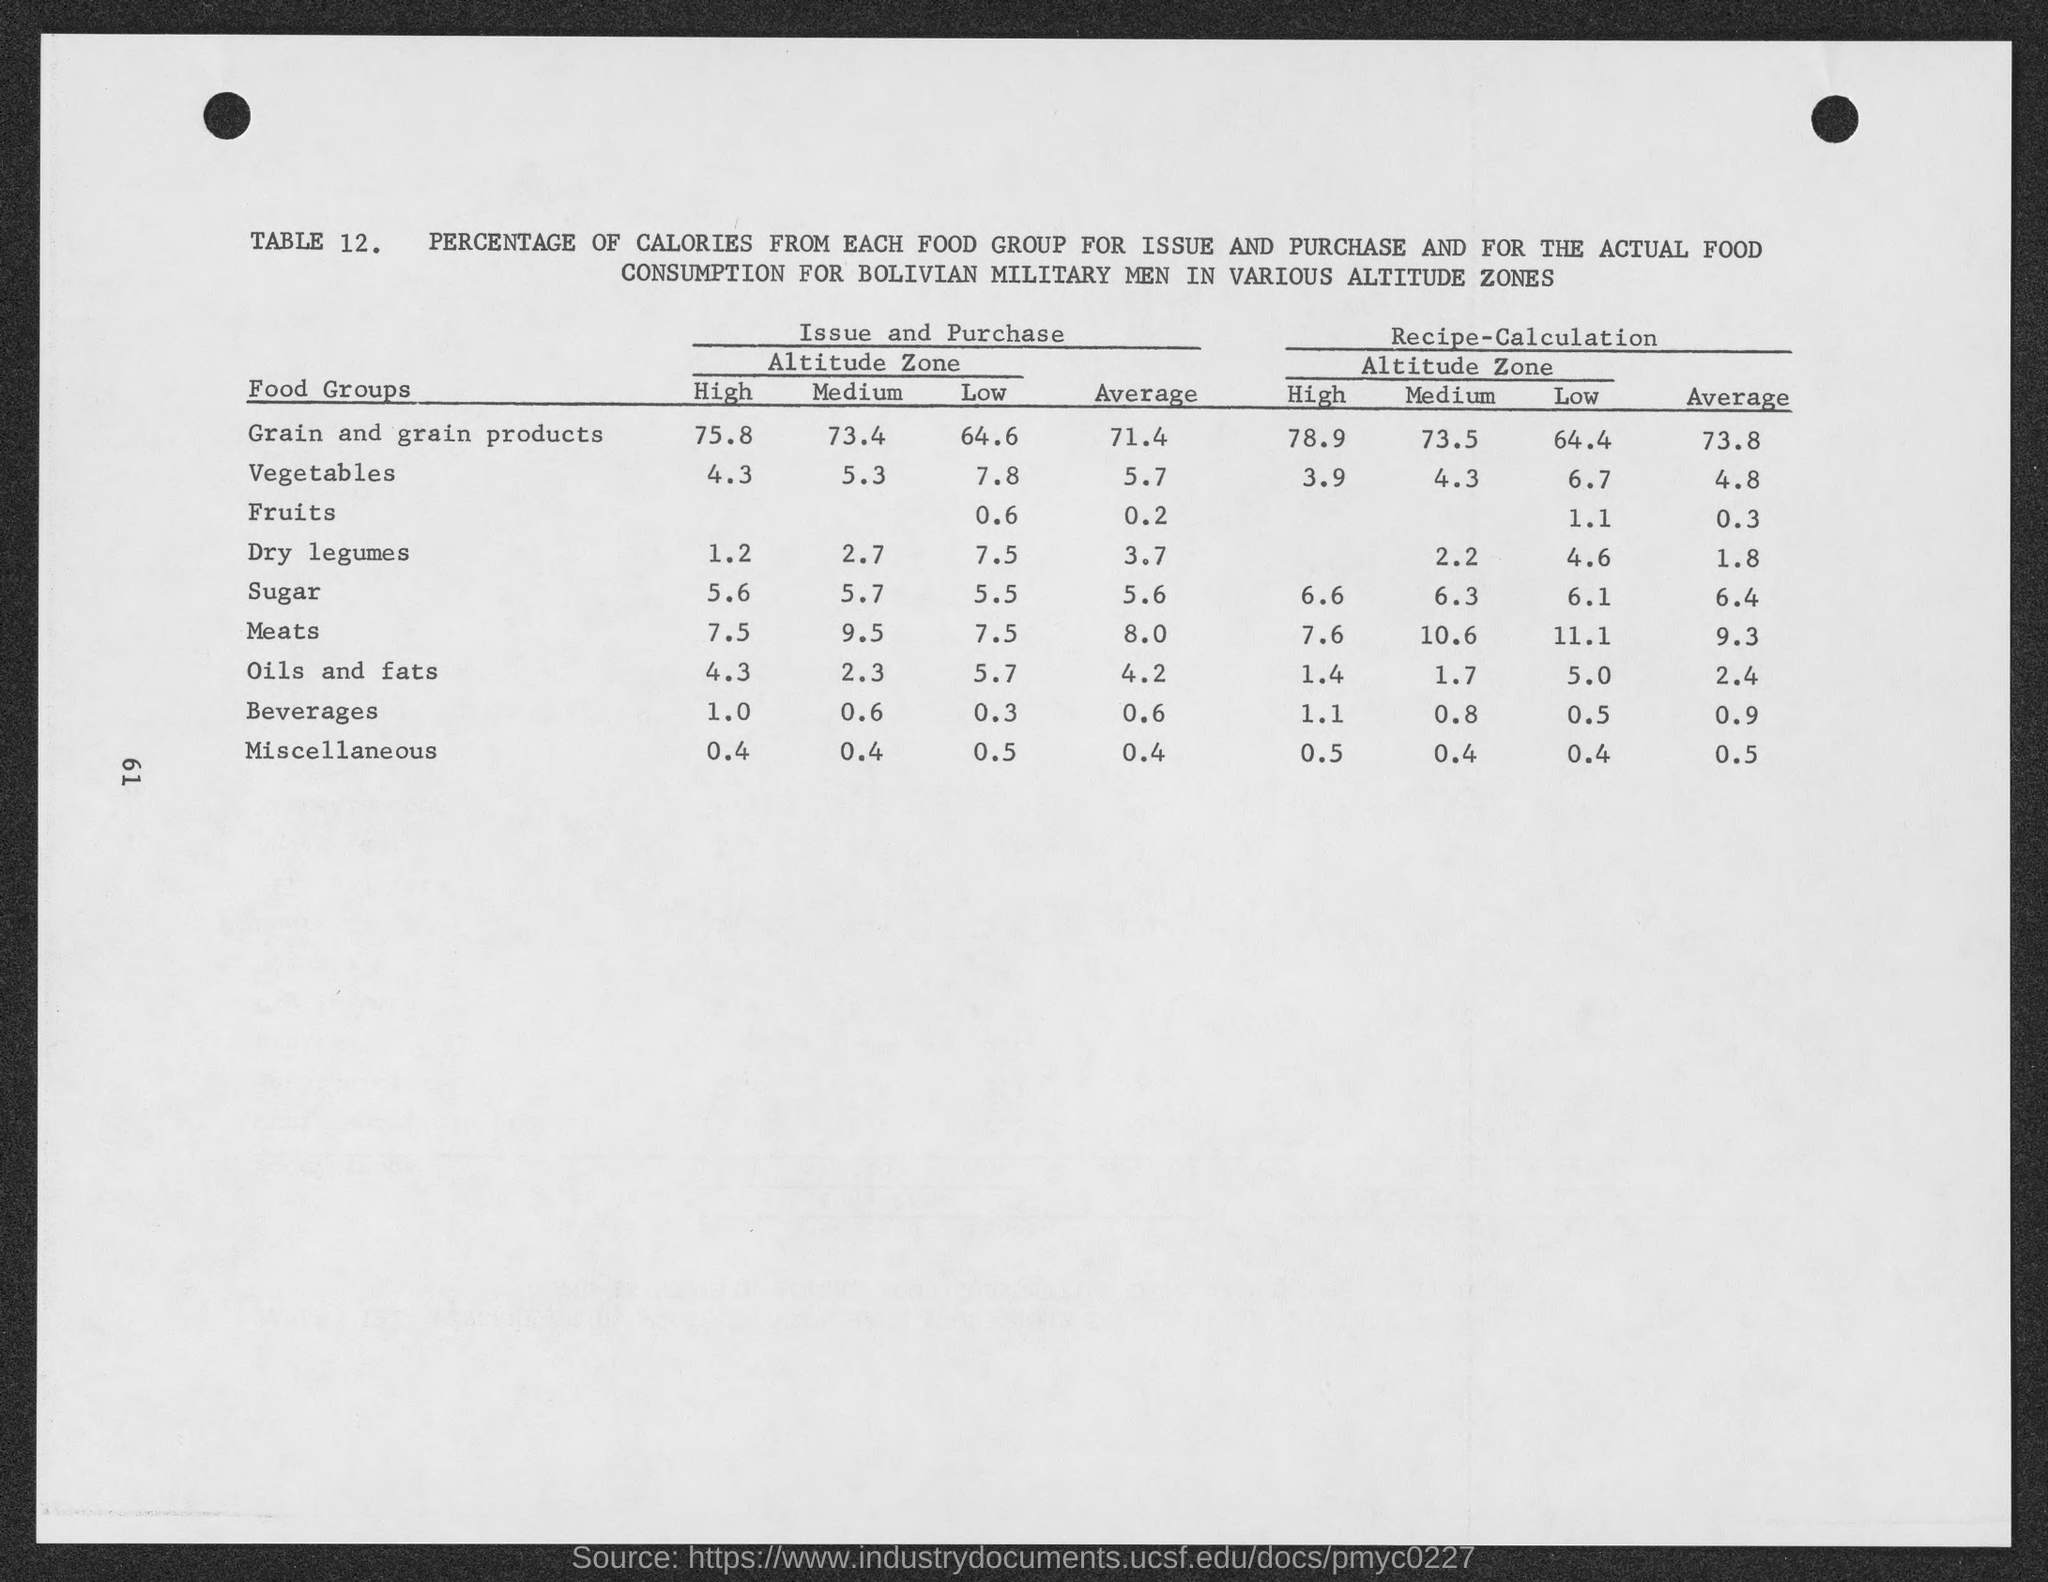How much is the average % of Recipe-Calculation in Grain and Grain products?
Your answer should be compact. 73.8. 